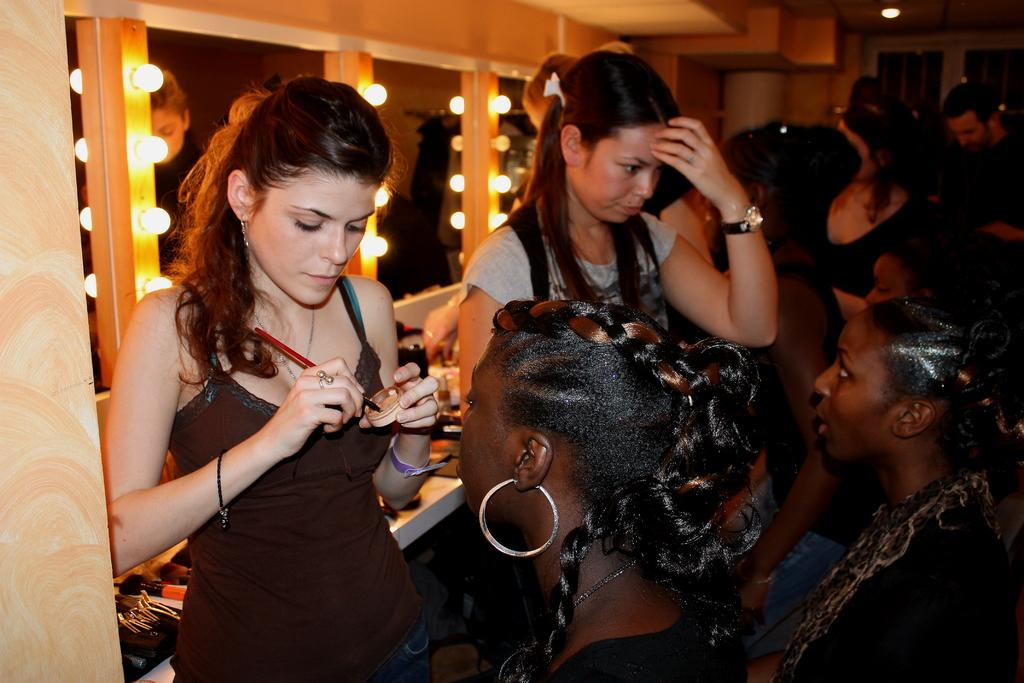What is the woman on the left side of the image doing? There is a woman performing makeup on the left side of the image. Can you describe the appearance of the woman performing makeup? The woman is beautiful. What color is the top worn by the woman performing makeup? The woman is wearing a black color top. Who are the other people in the image, and what are they doing? There are two women sitting on the right side of the image, and they are looking at the woman performing makeup. What type of car can be seen in the image? There is no car present in the image. What prose is being recited by the woman performing makeup? There is no mention of prose or any recitation in the image. 